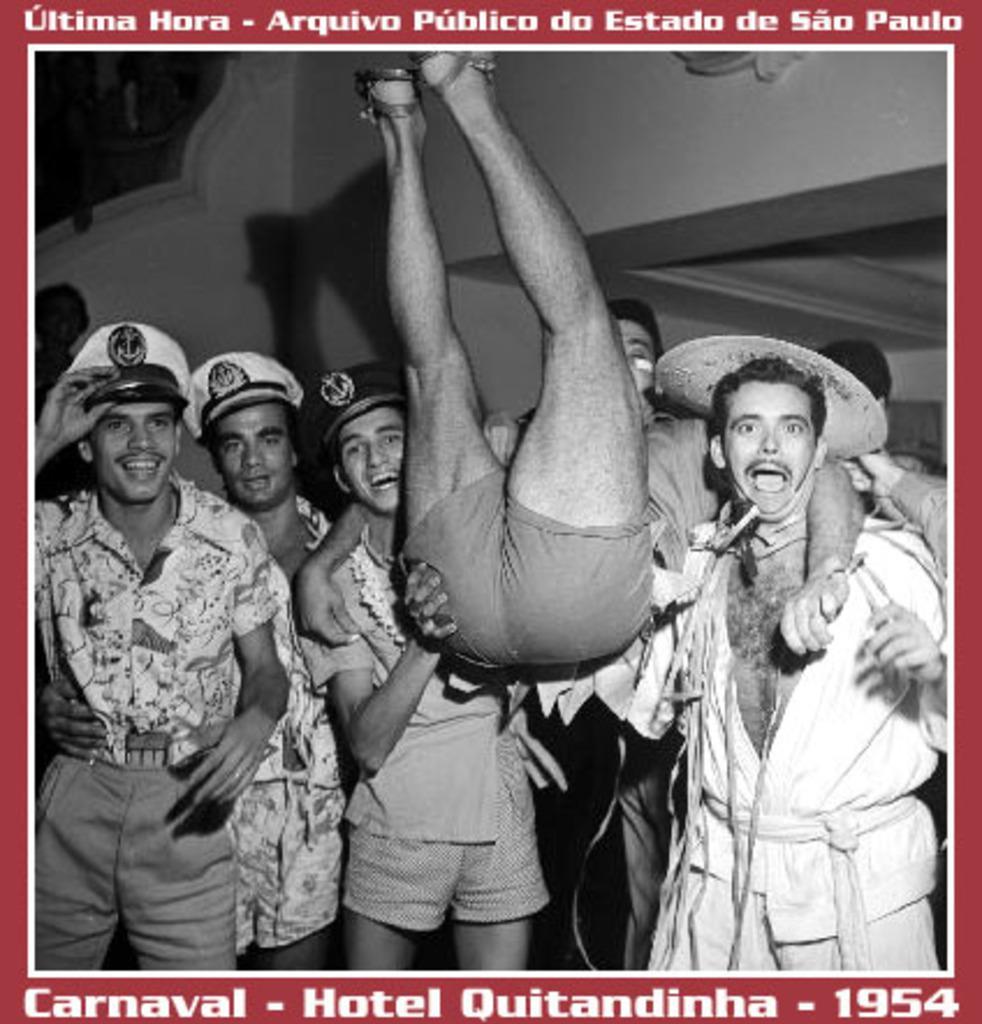How would you summarize this image in a sentence or two? In this image we can see a poster in which there are some group of persons standing also wearing caps, lifting a person and in the background of the image there is wall and there are some words written on it. 